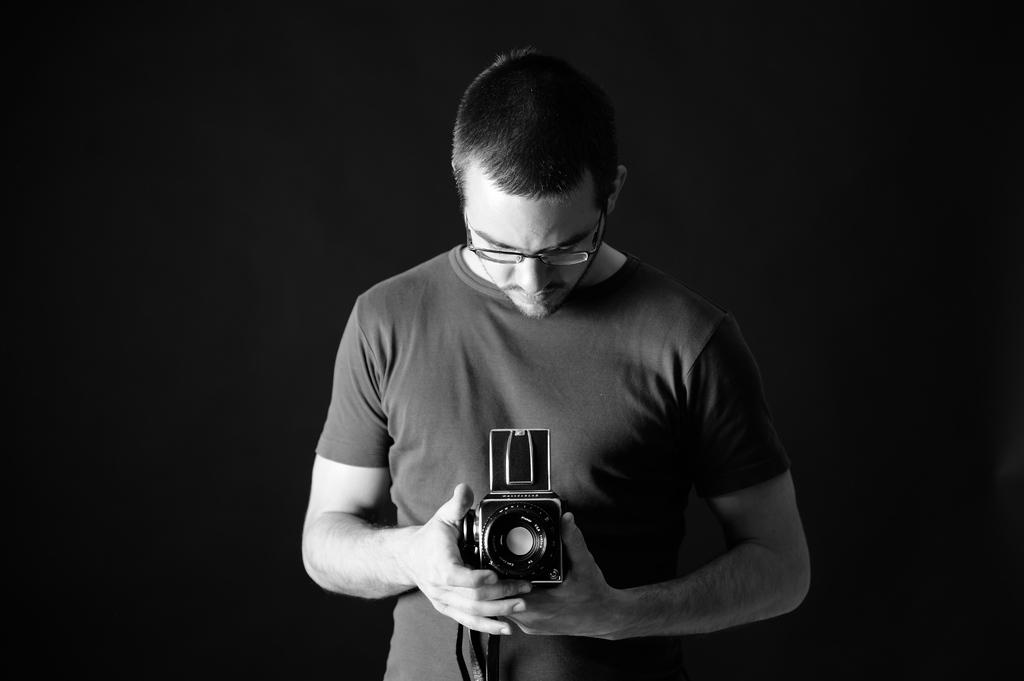Who is the main subject in the image? There is a man in the image. What is the man wearing? The man is wearing spectacles. What is the man's posture in the image? The man is standing. What is the man holding in his hands? The man is holding a camera in his hands. What is the man's focus in the image? The man is staring at the camera. Can you see any deer in the image? No, there are no deer present in the image. 